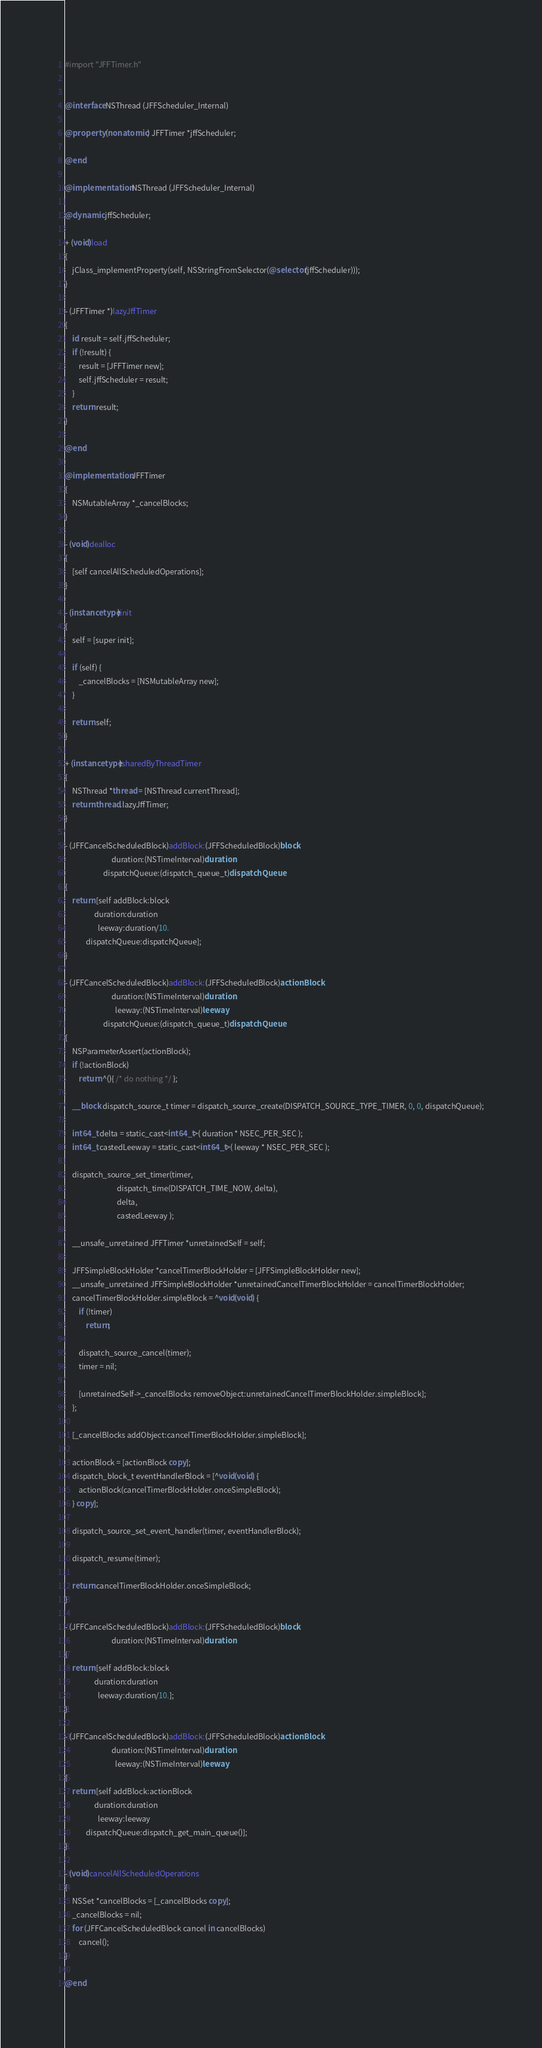<code> <loc_0><loc_0><loc_500><loc_500><_ObjectiveC_>#import "JFFTimer.h"


@interface NSThread (JFFScheduler_Internal)

@property (nonatomic) JFFTimer *jffScheduler;

@end

@implementation NSThread (JFFScheduler_Internal)

@dynamic jffScheduler;

+ (void)load
{
    jClass_implementProperty(self, NSStringFromSelector(@selector(jffScheduler)));
}

- (JFFTimer *)lazyJffTimer
{
    id result = self.jffScheduler;
    if (!result) {
        result = [JFFTimer new];
        self.jffScheduler = result;
    }
    return result;
}

@end

@implementation JFFTimer
{
    NSMutableArray *_cancelBlocks;
}

- (void)dealloc
{
    [self cancelAllScheduledOperations];
}

- (instancetype)init
{
    self = [super init];
    
    if (self) {
        _cancelBlocks = [NSMutableArray new];
    }
    
    return self;
}

+ (instancetype)sharedByThreadTimer
{
    NSThread *thread = [NSThread currentThread];
    return thread.lazyJffTimer;
}

- (JFFCancelScheduledBlock)addBlock:(JFFScheduledBlock)block
                           duration:(NSTimeInterval)duration
                      dispatchQueue:(dispatch_queue_t)dispatchQueue
{
    return [self addBlock:block
                 duration:duration
                   leeway:duration/10.
            dispatchQueue:dispatchQueue];
}

- (JFFCancelScheduledBlock)addBlock:(JFFScheduledBlock)actionBlock
                           duration:(NSTimeInterval)duration
                             leeway:(NSTimeInterval)leeway
                      dispatchQueue:(dispatch_queue_t)dispatchQueue
{
    NSParameterAssert(actionBlock);
    if (!actionBlock)
        return ^(){ /* do nothing */ };
    
    __block dispatch_source_t timer = dispatch_source_create(DISPATCH_SOURCE_TYPE_TIMER, 0, 0, dispatchQueue);
    
    int64_t delta = static_cast<int64_t>( duration * NSEC_PER_SEC );
    int64_t castedLeeway = static_cast<int64_t>( leeway * NSEC_PER_SEC );
    
    dispatch_source_set_timer(timer,
                              dispatch_time(DISPATCH_TIME_NOW, delta),
                              delta,
                              castedLeeway );
    
    __unsafe_unretained JFFTimer *unretainedSelf = self;
    
    JFFSimpleBlockHolder *cancelTimerBlockHolder = [JFFSimpleBlockHolder new];
    __unsafe_unretained JFFSimpleBlockHolder *unretainedCancelTimerBlockHolder = cancelTimerBlockHolder;
    cancelTimerBlockHolder.simpleBlock = ^void(void) {
        if (!timer)
            return;
        
        dispatch_source_cancel(timer);
        timer = nil;
        
        [unretainedSelf->_cancelBlocks removeObject:unretainedCancelTimerBlockHolder.simpleBlock];
    };
    
    [_cancelBlocks addObject:cancelTimerBlockHolder.simpleBlock];
    
    actionBlock = [actionBlock copy];
    dispatch_block_t eventHandlerBlock = [^void(void) {
        actionBlock(cancelTimerBlockHolder.onceSimpleBlock);
    } copy];
    
    dispatch_source_set_event_handler(timer, eventHandlerBlock);
    
    dispatch_resume(timer);
    
    return cancelTimerBlockHolder.onceSimpleBlock;
}

- (JFFCancelScheduledBlock)addBlock:(JFFScheduledBlock)block
                           duration:(NSTimeInterval)duration
{
    return [self addBlock:block
                 duration:duration
                   leeway:duration/10.];
}

- (JFFCancelScheduledBlock)addBlock:(JFFScheduledBlock)actionBlock
                           duration:(NSTimeInterval)duration
                             leeway:(NSTimeInterval)leeway
{
    return [self addBlock:actionBlock
                 duration:duration
                   leeway:leeway
            dispatchQueue:dispatch_get_main_queue()];
}

- (void)cancelAllScheduledOperations
{
    NSSet *cancelBlocks = [_cancelBlocks copy];
    _cancelBlocks = nil;
    for (JFFCancelScheduledBlock cancel in cancelBlocks)
        cancel();
}

@end
</code> 